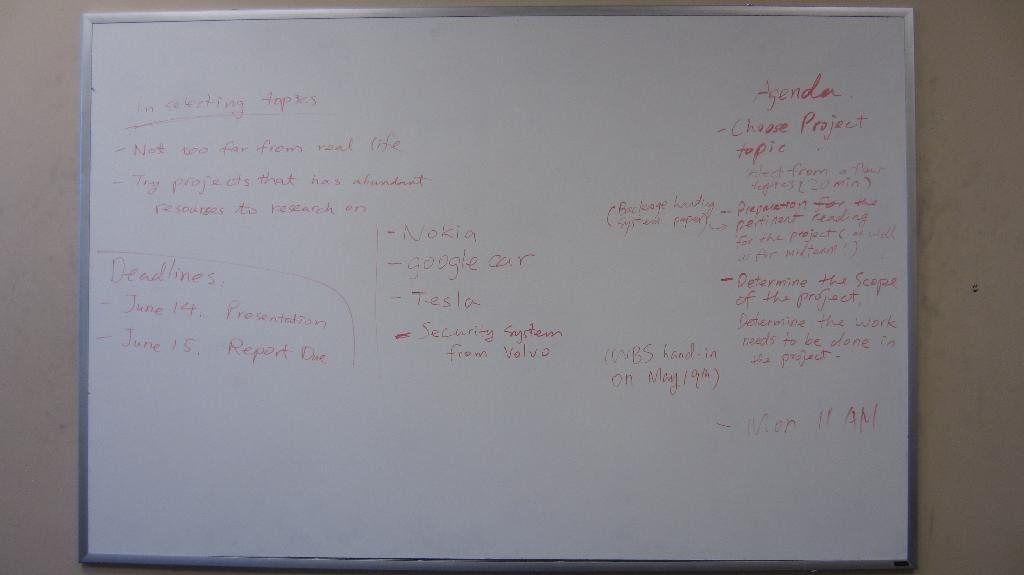<image>
Provide a brief description of the given image. White board with red wording and a word that says Agenda on the top right. 